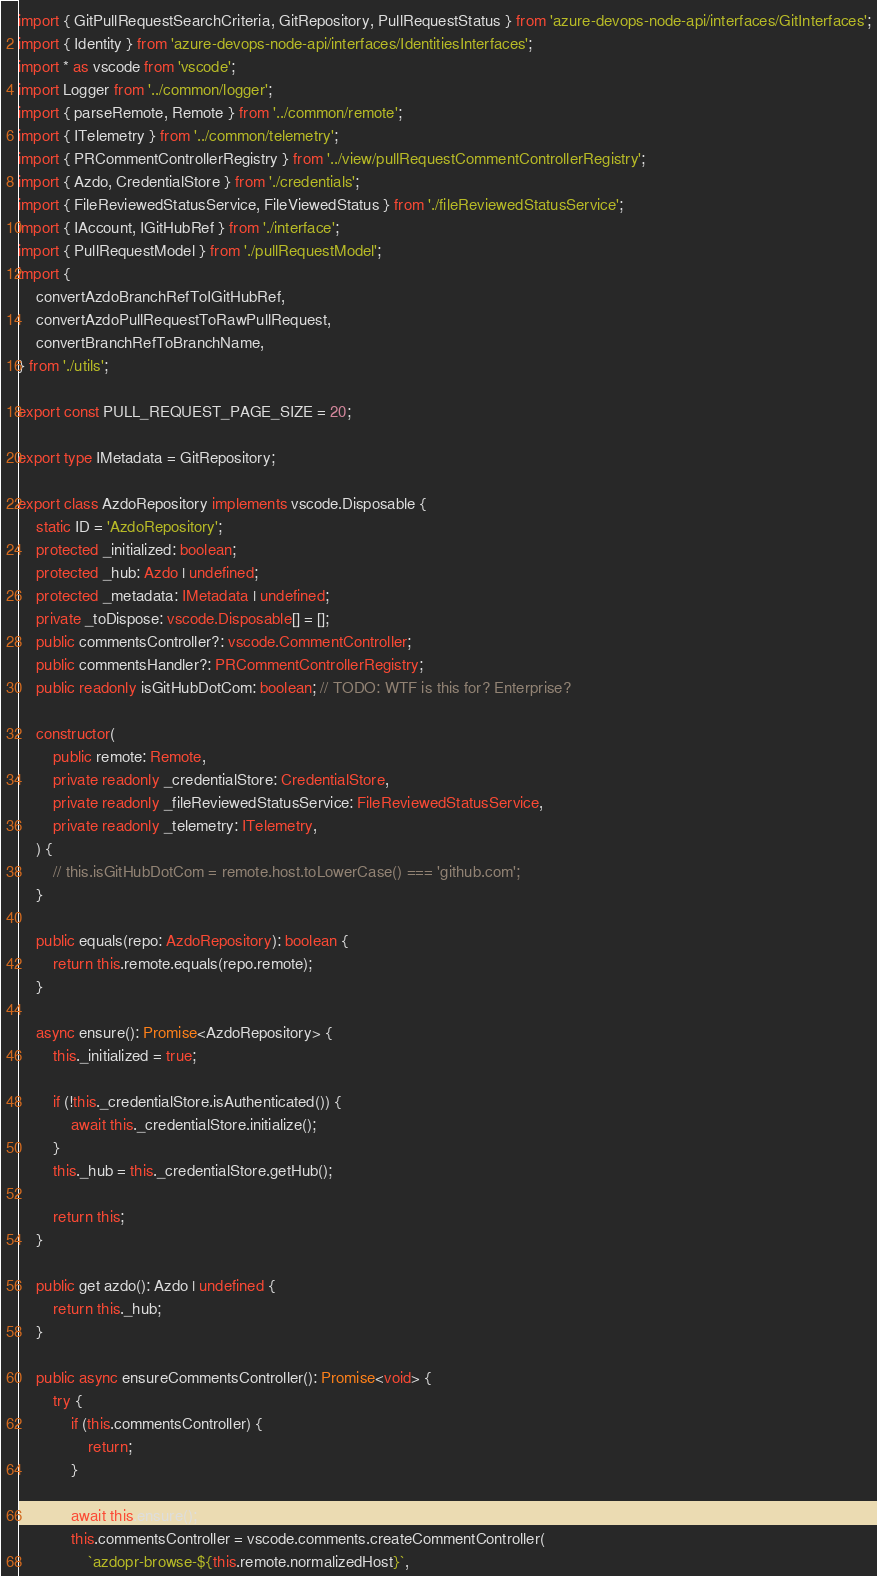Convert code to text. <code><loc_0><loc_0><loc_500><loc_500><_TypeScript_>import { GitPullRequestSearchCriteria, GitRepository, PullRequestStatus } from 'azure-devops-node-api/interfaces/GitInterfaces';
import { Identity } from 'azure-devops-node-api/interfaces/IdentitiesInterfaces';
import * as vscode from 'vscode';
import Logger from '../common/logger';
import { parseRemote, Remote } from '../common/remote';
import { ITelemetry } from '../common/telemetry';
import { PRCommentControllerRegistry } from '../view/pullRequestCommentControllerRegistry';
import { Azdo, CredentialStore } from './credentials';
import { FileReviewedStatusService, FileViewedStatus } from './fileReviewedStatusService';
import { IAccount, IGitHubRef } from './interface';
import { PullRequestModel } from './pullRequestModel';
import {
	convertAzdoBranchRefToIGitHubRef,
	convertAzdoPullRequestToRawPullRequest,
	convertBranchRefToBranchName,
} from './utils';

export const PULL_REQUEST_PAGE_SIZE = 20;

export type IMetadata = GitRepository;

export class AzdoRepository implements vscode.Disposable {
	static ID = 'AzdoRepository';
	protected _initialized: boolean;
	protected _hub: Azdo | undefined;
	protected _metadata: IMetadata | undefined;
	private _toDispose: vscode.Disposable[] = [];
	public commentsController?: vscode.CommentController;
	public commentsHandler?: PRCommentControllerRegistry;
	public readonly isGitHubDotCom: boolean; // TODO: WTF is this for? Enterprise?

	constructor(
		public remote: Remote,
		private readonly _credentialStore: CredentialStore,
		private readonly _fileReviewedStatusService: FileReviewedStatusService,
		private readonly _telemetry: ITelemetry,
	) {
		// this.isGitHubDotCom = remote.host.toLowerCase() === 'github.com';
	}

	public equals(repo: AzdoRepository): boolean {
		return this.remote.equals(repo.remote);
	}

	async ensure(): Promise<AzdoRepository> {
		this._initialized = true;

		if (!this._credentialStore.isAuthenticated()) {
			await this._credentialStore.initialize();
		}
		this._hub = this._credentialStore.getHub();

		return this;
	}

	public get azdo(): Azdo | undefined {
		return this._hub;
	}

	public async ensureCommentsController(): Promise<void> {
		try {
			if (this.commentsController) {
				return;
			}

			await this.ensure();
			this.commentsController = vscode.comments.createCommentController(
				`azdopr-browse-${this.remote.normalizedHost}`,</code> 